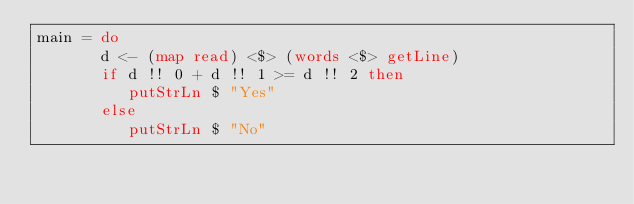<code> <loc_0><loc_0><loc_500><loc_500><_Haskell_>main = do
       d <- (map read) <$> (words <$> getLine)
       if d !! 0 + d !! 1 >= d !! 2 then
          putStrLn $ "Yes"
       else
          putStrLn $ "No"</code> 